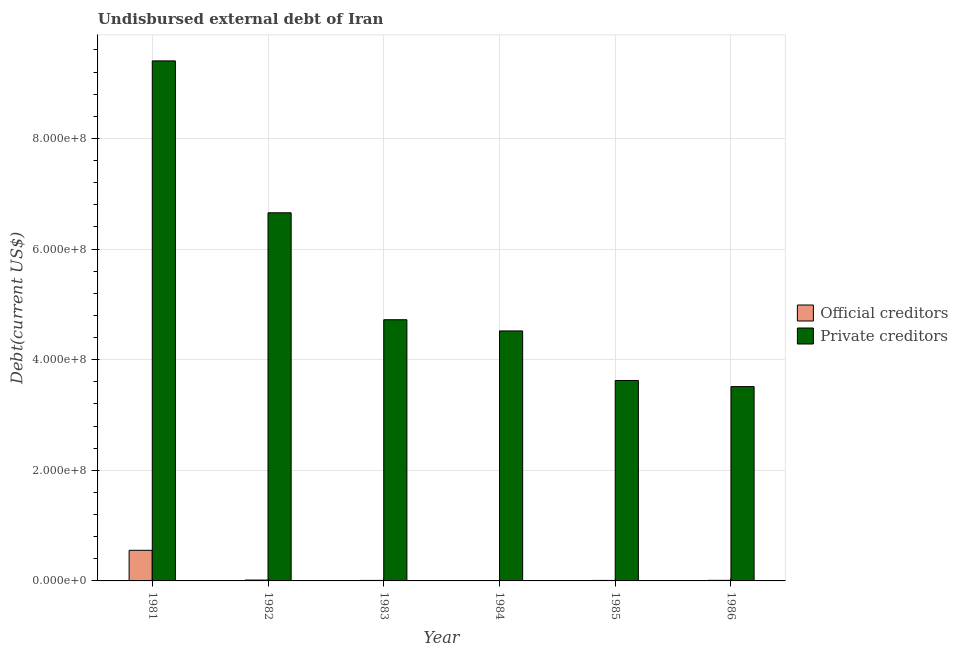How many different coloured bars are there?
Offer a very short reply. 2. How many groups of bars are there?
Your response must be concise. 6. Are the number of bars per tick equal to the number of legend labels?
Provide a short and direct response. Yes. Are the number of bars on each tick of the X-axis equal?
Keep it short and to the point. Yes. How many bars are there on the 6th tick from the right?
Keep it short and to the point. 2. What is the label of the 2nd group of bars from the left?
Give a very brief answer. 1982. In how many cases, is the number of bars for a given year not equal to the number of legend labels?
Offer a very short reply. 0. What is the undisbursed external debt of private creditors in 1983?
Ensure brevity in your answer.  4.72e+08. Across all years, what is the maximum undisbursed external debt of official creditors?
Your response must be concise. 5.54e+07. Across all years, what is the minimum undisbursed external debt of official creditors?
Your answer should be compact. 6.73e+05. In which year was the undisbursed external debt of private creditors minimum?
Give a very brief answer. 1986. What is the total undisbursed external debt of official creditors in the graph?
Provide a succinct answer. 6.04e+07. What is the difference between the undisbursed external debt of private creditors in 1983 and that in 1984?
Your answer should be compact. 2.03e+07. What is the difference between the undisbursed external debt of official creditors in 1986 and the undisbursed external debt of private creditors in 1982?
Offer a terse response. -4.95e+05. What is the average undisbursed external debt of private creditors per year?
Offer a very short reply. 5.41e+08. In the year 1986, what is the difference between the undisbursed external debt of official creditors and undisbursed external debt of private creditors?
Your response must be concise. 0. In how many years, is the undisbursed external debt of official creditors greater than 800000000 US$?
Provide a succinct answer. 0. What is the ratio of the undisbursed external debt of official creditors in 1981 to that in 1986?
Keep it short and to the point. 52.47. Is the undisbursed external debt of official creditors in 1983 less than that in 1986?
Give a very brief answer. Yes. What is the difference between the highest and the second highest undisbursed external debt of private creditors?
Provide a succinct answer. 2.75e+08. What is the difference between the highest and the lowest undisbursed external debt of private creditors?
Your answer should be very brief. 5.89e+08. Is the sum of the undisbursed external debt of official creditors in 1981 and 1983 greater than the maximum undisbursed external debt of private creditors across all years?
Provide a succinct answer. Yes. What does the 1st bar from the left in 1983 represents?
Provide a short and direct response. Official creditors. What does the 2nd bar from the right in 1981 represents?
Your response must be concise. Official creditors. How many bars are there?
Ensure brevity in your answer.  12. What is the difference between two consecutive major ticks on the Y-axis?
Provide a short and direct response. 2.00e+08. Are the values on the major ticks of Y-axis written in scientific E-notation?
Provide a short and direct response. Yes. Where does the legend appear in the graph?
Give a very brief answer. Center right. What is the title of the graph?
Make the answer very short. Undisbursed external debt of Iran. Does "Lowest 20% of population" appear as one of the legend labels in the graph?
Offer a very short reply. No. What is the label or title of the Y-axis?
Your answer should be very brief. Debt(current US$). What is the Debt(current US$) of Official creditors in 1981?
Keep it short and to the point. 5.54e+07. What is the Debt(current US$) in Private creditors in 1981?
Your answer should be very brief. 9.40e+08. What is the Debt(current US$) in Official creditors in 1982?
Provide a short and direct response. 1.55e+06. What is the Debt(current US$) of Private creditors in 1982?
Offer a terse response. 6.66e+08. What is the Debt(current US$) of Official creditors in 1983?
Provide a short and direct response. 9.22e+05. What is the Debt(current US$) of Private creditors in 1983?
Provide a succinct answer. 4.72e+08. What is the Debt(current US$) in Official creditors in 1984?
Offer a terse response. 6.73e+05. What is the Debt(current US$) of Private creditors in 1984?
Your answer should be compact. 4.52e+08. What is the Debt(current US$) of Official creditors in 1985?
Make the answer very short. 8.89e+05. What is the Debt(current US$) of Private creditors in 1985?
Offer a terse response. 3.62e+08. What is the Debt(current US$) in Official creditors in 1986?
Ensure brevity in your answer.  1.06e+06. What is the Debt(current US$) of Private creditors in 1986?
Your answer should be compact. 3.51e+08. Across all years, what is the maximum Debt(current US$) in Official creditors?
Make the answer very short. 5.54e+07. Across all years, what is the maximum Debt(current US$) of Private creditors?
Offer a terse response. 9.40e+08. Across all years, what is the minimum Debt(current US$) of Official creditors?
Provide a short and direct response. 6.73e+05. Across all years, what is the minimum Debt(current US$) in Private creditors?
Provide a short and direct response. 3.51e+08. What is the total Debt(current US$) in Official creditors in the graph?
Make the answer very short. 6.04e+07. What is the total Debt(current US$) in Private creditors in the graph?
Your answer should be compact. 3.24e+09. What is the difference between the Debt(current US$) in Official creditors in 1981 and that in 1982?
Make the answer very short. 5.38e+07. What is the difference between the Debt(current US$) in Private creditors in 1981 and that in 1982?
Ensure brevity in your answer.  2.75e+08. What is the difference between the Debt(current US$) in Official creditors in 1981 and that in 1983?
Give a very brief answer. 5.44e+07. What is the difference between the Debt(current US$) of Private creditors in 1981 and that in 1983?
Offer a terse response. 4.68e+08. What is the difference between the Debt(current US$) of Official creditors in 1981 and that in 1984?
Your answer should be very brief. 5.47e+07. What is the difference between the Debt(current US$) in Private creditors in 1981 and that in 1984?
Your response must be concise. 4.88e+08. What is the difference between the Debt(current US$) of Official creditors in 1981 and that in 1985?
Ensure brevity in your answer.  5.45e+07. What is the difference between the Debt(current US$) in Private creditors in 1981 and that in 1985?
Make the answer very short. 5.78e+08. What is the difference between the Debt(current US$) of Official creditors in 1981 and that in 1986?
Give a very brief answer. 5.43e+07. What is the difference between the Debt(current US$) in Private creditors in 1981 and that in 1986?
Keep it short and to the point. 5.89e+08. What is the difference between the Debt(current US$) in Official creditors in 1982 and that in 1983?
Make the answer very short. 6.28e+05. What is the difference between the Debt(current US$) in Private creditors in 1982 and that in 1983?
Ensure brevity in your answer.  1.93e+08. What is the difference between the Debt(current US$) of Official creditors in 1982 and that in 1984?
Keep it short and to the point. 8.77e+05. What is the difference between the Debt(current US$) of Private creditors in 1982 and that in 1984?
Provide a short and direct response. 2.14e+08. What is the difference between the Debt(current US$) of Official creditors in 1982 and that in 1985?
Offer a terse response. 6.61e+05. What is the difference between the Debt(current US$) in Private creditors in 1982 and that in 1985?
Offer a terse response. 3.03e+08. What is the difference between the Debt(current US$) of Official creditors in 1982 and that in 1986?
Ensure brevity in your answer.  4.95e+05. What is the difference between the Debt(current US$) in Private creditors in 1982 and that in 1986?
Provide a succinct answer. 3.14e+08. What is the difference between the Debt(current US$) of Official creditors in 1983 and that in 1984?
Ensure brevity in your answer.  2.49e+05. What is the difference between the Debt(current US$) of Private creditors in 1983 and that in 1984?
Your answer should be very brief. 2.03e+07. What is the difference between the Debt(current US$) in Official creditors in 1983 and that in 1985?
Ensure brevity in your answer.  3.30e+04. What is the difference between the Debt(current US$) in Private creditors in 1983 and that in 1985?
Your response must be concise. 1.10e+08. What is the difference between the Debt(current US$) in Official creditors in 1983 and that in 1986?
Make the answer very short. -1.33e+05. What is the difference between the Debt(current US$) in Private creditors in 1983 and that in 1986?
Provide a short and direct response. 1.21e+08. What is the difference between the Debt(current US$) of Official creditors in 1984 and that in 1985?
Your answer should be very brief. -2.16e+05. What is the difference between the Debt(current US$) in Private creditors in 1984 and that in 1985?
Keep it short and to the point. 8.96e+07. What is the difference between the Debt(current US$) in Official creditors in 1984 and that in 1986?
Make the answer very short. -3.82e+05. What is the difference between the Debt(current US$) in Private creditors in 1984 and that in 1986?
Your answer should be very brief. 1.01e+08. What is the difference between the Debt(current US$) in Official creditors in 1985 and that in 1986?
Provide a succinct answer. -1.66e+05. What is the difference between the Debt(current US$) in Private creditors in 1985 and that in 1986?
Your answer should be very brief. 1.10e+07. What is the difference between the Debt(current US$) of Official creditors in 1981 and the Debt(current US$) of Private creditors in 1982?
Your response must be concise. -6.10e+08. What is the difference between the Debt(current US$) in Official creditors in 1981 and the Debt(current US$) in Private creditors in 1983?
Your response must be concise. -4.17e+08. What is the difference between the Debt(current US$) in Official creditors in 1981 and the Debt(current US$) in Private creditors in 1984?
Offer a terse response. -3.97e+08. What is the difference between the Debt(current US$) in Official creditors in 1981 and the Debt(current US$) in Private creditors in 1985?
Your answer should be very brief. -3.07e+08. What is the difference between the Debt(current US$) in Official creditors in 1981 and the Debt(current US$) in Private creditors in 1986?
Provide a short and direct response. -2.96e+08. What is the difference between the Debt(current US$) of Official creditors in 1982 and the Debt(current US$) of Private creditors in 1983?
Your response must be concise. -4.71e+08. What is the difference between the Debt(current US$) in Official creditors in 1982 and the Debt(current US$) in Private creditors in 1984?
Your response must be concise. -4.50e+08. What is the difference between the Debt(current US$) of Official creditors in 1982 and the Debt(current US$) of Private creditors in 1985?
Give a very brief answer. -3.61e+08. What is the difference between the Debt(current US$) of Official creditors in 1982 and the Debt(current US$) of Private creditors in 1986?
Give a very brief answer. -3.50e+08. What is the difference between the Debt(current US$) of Official creditors in 1983 and the Debt(current US$) of Private creditors in 1984?
Make the answer very short. -4.51e+08. What is the difference between the Debt(current US$) of Official creditors in 1983 and the Debt(current US$) of Private creditors in 1985?
Give a very brief answer. -3.61e+08. What is the difference between the Debt(current US$) in Official creditors in 1983 and the Debt(current US$) in Private creditors in 1986?
Give a very brief answer. -3.50e+08. What is the difference between the Debt(current US$) in Official creditors in 1984 and the Debt(current US$) in Private creditors in 1985?
Ensure brevity in your answer.  -3.62e+08. What is the difference between the Debt(current US$) of Official creditors in 1984 and the Debt(current US$) of Private creditors in 1986?
Keep it short and to the point. -3.51e+08. What is the difference between the Debt(current US$) of Official creditors in 1985 and the Debt(current US$) of Private creditors in 1986?
Provide a short and direct response. -3.50e+08. What is the average Debt(current US$) in Official creditors per year?
Make the answer very short. 1.01e+07. What is the average Debt(current US$) of Private creditors per year?
Ensure brevity in your answer.  5.41e+08. In the year 1981, what is the difference between the Debt(current US$) of Official creditors and Debt(current US$) of Private creditors?
Offer a very short reply. -8.85e+08. In the year 1982, what is the difference between the Debt(current US$) of Official creditors and Debt(current US$) of Private creditors?
Offer a terse response. -6.64e+08. In the year 1983, what is the difference between the Debt(current US$) of Official creditors and Debt(current US$) of Private creditors?
Give a very brief answer. -4.71e+08. In the year 1984, what is the difference between the Debt(current US$) of Official creditors and Debt(current US$) of Private creditors?
Ensure brevity in your answer.  -4.51e+08. In the year 1985, what is the difference between the Debt(current US$) of Official creditors and Debt(current US$) of Private creditors?
Provide a short and direct response. -3.62e+08. In the year 1986, what is the difference between the Debt(current US$) in Official creditors and Debt(current US$) in Private creditors?
Ensure brevity in your answer.  -3.50e+08. What is the ratio of the Debt(current US$) in Official creditors in 1981 to that in 1982?
Ensure brevity in your answer.  35.72. What is the ratio of the Debt(current US$) in Private creditors in 1981 to that in 1982?
Provide a succinct answer. 1.41. What is the ratio of the Debt(current US$) of Official creditors in 1981 to that in 1983?
Your response must be concise. 60.04. What is the ratio of the Debt(current US$) in Private creditors in 1981 to that in 1983?
Keep it short and to the point. 1.99. What is the ratio of the Debt(current US$) of Official creditors in 1981 to that in 1984?
Provide a succinct answer. 82.26. What is the ratio of the Debt(current US$) in Private creditors in 1981 to that in 1984?
Offer a terse response. 2.08. What is the ratio of the Debt(current US$) in Official creditors in 1981 to that in 1985?
Offer a very short reply. 62.27. What is the ratio of the Debt(current US$) in Private creditors in 1981 to that in 1985?
Your answer should be very brief. 2.59. What is the ratio of the Debt(current US$) in Official creditors in 1981 to that in 1986?
Keep it short and to the point. 52.47. What is the ratio of the Debt(current US$) in Private creditors in 1981 to that in 1986?
Provide a succinct answer. 2.68. What is the ratio of the Debt(current US$) of Official creditors in 1982 to that in 1983?
Make the answer very short. 1.68. What is the ratio of the Debt(current US$) of Private creditors in 1982 to that in 1983?
Offer a terse response. 1.41. What is the ratio of the Debt(current US$) of Official creditors in 1982 to that in 1984?
Your answer should be compact. 2.3. What is the ratio of the Debt(current US$) of Private creditors in 1982 to that in 1984?
Give a very brief answer. 1.47. What is the ratio of the Debt(current US$) in Official creditors in 1982 to that in 1985?
Your answer should be compact. 1.74. What is the ratio of the Debt(current US$) of Private creditors in 1982 to that in 1985?
Ensure brevity in your answer.  1.84. What is the ratio of the Debt(current US$) of Official creditors in 1982 to that in 1986?
Provide a succinct answer. 1.47. What is the ratio of the Debt(current US$) of Private creditors in 1982 to that in 1986?
Make the answer very short. 1.89. What is the ratio of the Debt(current US$) in Official creditors in 1983 to that in 1984?
Offer a very short reply. 1.37. What is the ratio of the Debt(current US$) of Private creditors in 1983 to that in 1984?
Provide a succinct answer. 1.04. What is the ratio of the Debt(current US$) of Official creditors in 1983 to that in 1985?
Your answer should be compact. 1.04. What is the ratio of the Debt(current US$) of Private creditors in 1983 to that in 1985?
Your answer should be compact. 1.3. What is the ratio of the Debt(current US$) in Official creditors in 1983 to that in 1986?
Provide a succinct answer. 0.87. What is the ratio of the Debt(current US$) in Private creditors in 1983 to that in 1986?
Your answer should be compact. 1.34. What is the ratio of the Debt(current US$) of Official creditors in 1984 to that in 1985?
Your answer should be very brief. 0.76. What is the ratio of the Debt(current US$) of Private creditors in 1984 to that in 1985?
Provide a succinct answer. 1.25. What is the ratio of the Debt(current US$) of Official creditors in 1984 to that in 1986?
Your response must be concise. 0.64. What is the ratio of the Debt(current US$) in Private creditors in 1984 to that in 1986?
Your answer should be compact. 1.29. What is the ratio of the Debt(current US$) in Official creditors in 1985 to that in 1986?
Your answer should be compact. 0.84. What is the ratio of the Debt(current US$) of Private creditors in 1985 to that in 1986?
Provide a succinct answer. 1.03. What is the difference between the highest and the second highest Debt(current US$) of Official creditors?
Provide a short and direct response. 5.38e+07. What is the difference between the highest and the second highest Debt(current US$) of Private creditors?
Give a very brief answer. 2.75e+08. What is the difference between the highest and the lowest Debt(current US$) of Official creditors?
Provide a succinct answer. 5.47e+07. What is the difference between the highest and the lowest Debt(current US$) in Private creditors?
Ensure brevity in your answer.  5.89e+08. 